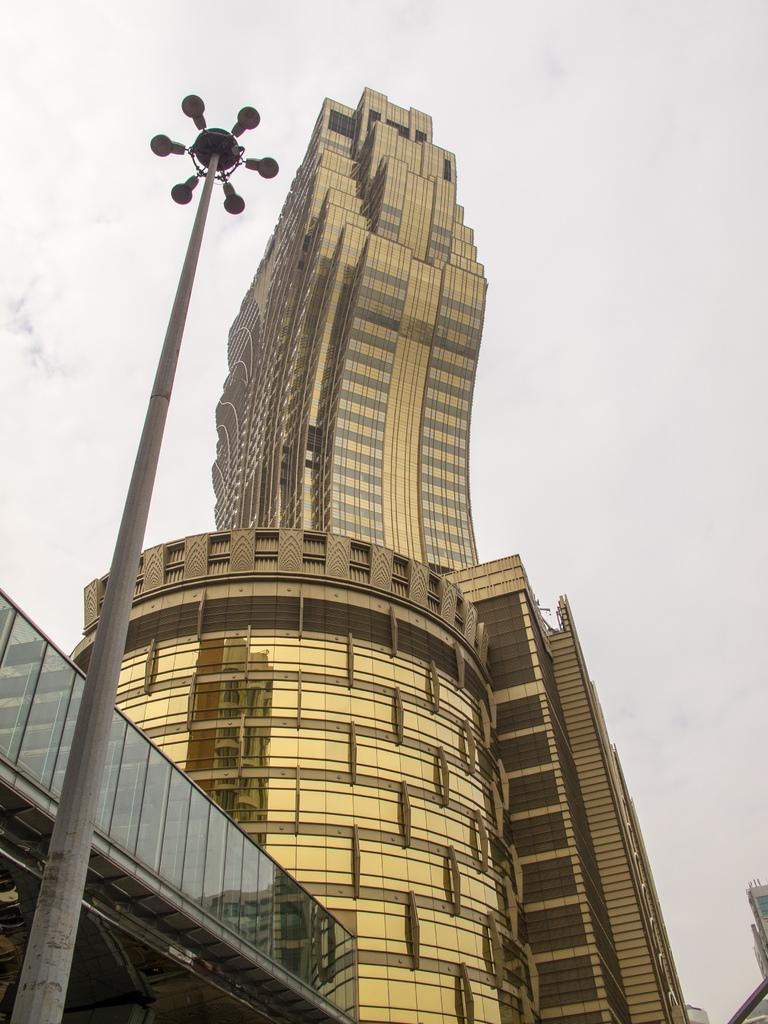What is the main subject in the center of the image? There is a building in the center of the image. What other object can be seen in the image? There is a street light in the image. What is visible at the top of the image? The sky is visible at the top of the image. What is the writer doing in the image? There is no writer present in the image. Is it raining in the image? There is no indication of rain in the image. 